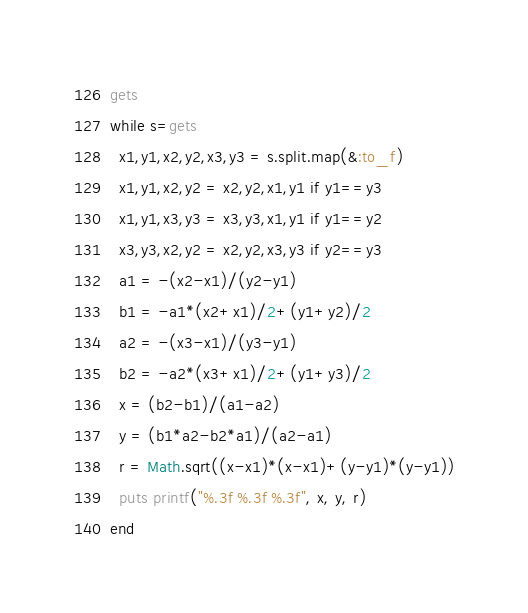<code> <loc_0><loc_0><loc_500><loc_500><_Ruby_>gets
while s=gets
  x1,y1,x2,y2,x3,y3 = s.split.map(&:to_f)
  x1,y1,x2,y2 = x2,y2,x1,y1 if y1==y3
  x1,y1,x3,y3 = x3,y3,x1,y1 if y1==y2
  x3,y3,x2,y2 = x2,y2,x3,y3 if y2==y3
  a1 = -(x2-x1)/(y2-y1)
  b1 = -a1*(x2+x1)/2+(y1+y2)/2
  a2 = -(x3-x1)/(y3-y1)
  b2 = -a2*(x3+x1)/2+(y1+y3)/2
  x = (b2-b1)/(a1-a2)
  y = (b1*a2-b2*a1)/(a2-a1)
  r = Math.sqrt((x-x1)*(x-x1)+(y-y1)*(y-y1))
  puts printf("%.3f %.3f %.3f", x, y, r)
end</code> 